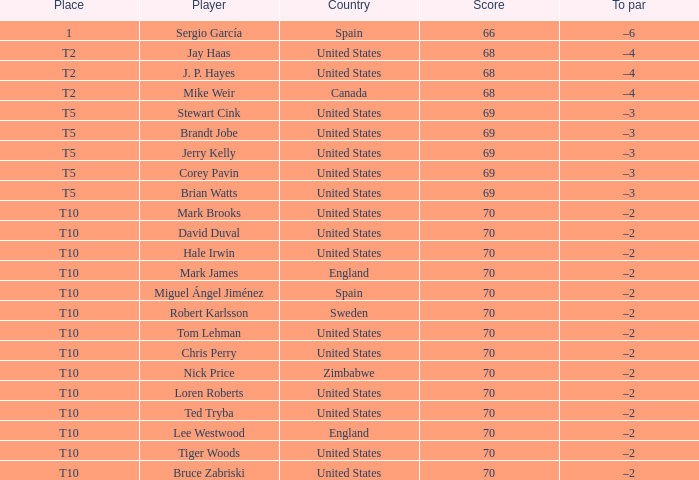What place did player mark brooks take? T10. 